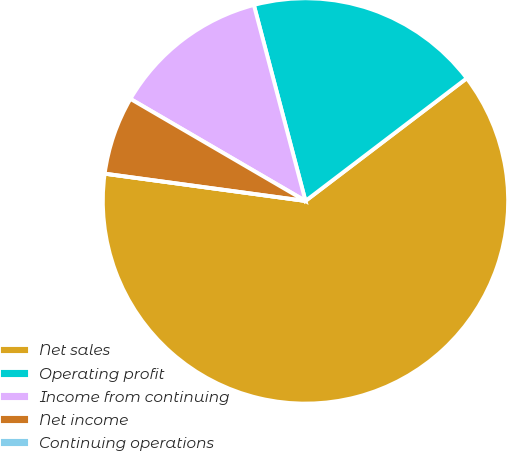Convert chart. <chart><loc_0><loc_0><loc_500><loc_500><pie_chart><fcel>Net sales<fcel>Operating profit<fcel>Income from continuing<fcel>Net income<fcel>Continuing operations<nl><fcel>62.5%<fcel>18.75%<fcel>12.5%<fcel>6.25%<fcel>0.0%<nl></chart> 